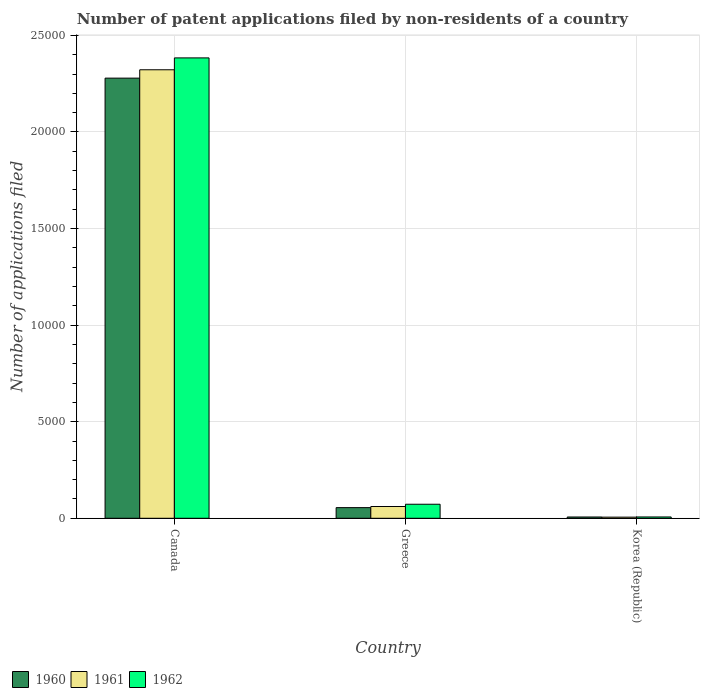How many different coloured bars are there?
Provide a short and direct response. 3. What is the label of the 2nd group of bars from the left?
Your response must be concise. Greece. In how many cases, is the number of bars for a given country not equal to the number of legend labels?
Provide a succinct answer. 0. Across all countries, what is the maximum number of applications filed in 1960?
Offer a very short reply. 2.28e+04. Across all countries, what is the minimum number of applications filed in 1960?
Give a very brief answer. 66. What is the total number of applications filed in 1960 in the graph?
Your response must be concise. 2.34e+04. What is the difference between the number of applications filed in 1960 in Canada and that in Greece?
Provide a succinct answer. 2.22e+04. What is the difference between the number of applications filed in 1961 in Greece and the number of applications filed in 1960 in Canada?
Your answer should be compact. -2.22e+04. What is the average number of applications filed in 1962 per country?
Provide a succinct answer. 8209.33. What is the difference between the number of applications filed of/in 1960 and number of applications filed of/in 1962 in Canada?
Provide a succinct answer. -1048. What is the ratio of the number of applications filed in 1961 in Canada to that in Greece?
Your answer should be very brief. 38.13. Is the difference between the number of applications filed in 1960 in Greece and Korea (Republic) greater than the difference between the number of applications filed in 1962 in Greece and Korea (Republic)?
Provide a succinct answer. No. What is the difference between the highest and the second highest number of applications filed in 1962?
Offer a terse response. 2.38e+04. What is the difference between the highest and the lowest number of applications filed in 1962?
Give a very brief answer. 2.38e+04. Are all the bars in the graph horizontal?
Provide a succinct answer. No. What is the difference between two consecutive major ticks on the Y-axis?
Keep it short and to the point. 5000. Does the graph contain any zero values?
Make the answer very short. No. Where does the legend appear in the graph?
Your answer should be very brief. Bottom left. How many legend labels are there?
Make the answer very short. 3. What is the title of the graph?
Provide a short and direct response. Number of patent applications filed by non-residents of a country. What is the label or title of the Y-axis?
Provide a succinct answer. Number of applications filed. What is the Number of applications filed in 1960 in Canada?
Your answer should be very brief. 2.28e+04. What is the Number of applications filed of 1961 in Canada?
Your answer should be very brief. 2.32e+04. What is the Number of applications filed of 1962 in Canada?
Offer a terse response. 2.38e+04. What is the Number of applications filed in 1960 in Greece?
Provide a succinct answer. 551. What is the Number of applications filed of 1961 in Greece?
Ensure brevity in your answer.  609. What is the Number of applications filed in 1962 in Greece?
Provide a succinct answer. 726. What is the Number of applications filed in 1961 in Korea (Republic)?
Give a very brief answer. 58. What is the Number of applications filed in 1962 in Korea (Republic)?
Keep it short and to the point. 68. Across all countries, what is the maximum Number of applications filed in 1960?
Provide a short and direct response. 2.28e+04. Across all countries, what is the maximum Number of applications filed in 1961?
Your answer should be very brief. 2.32e+04. Across all countries, what is the maximum Number of applications filed of 1962?
Provide a short and direct response. 2.38e+04. Across all countries, what is the minimum Number of applications filed in 1960?
Ensure brevity in your answer.  66. Across all countries, what is the minimum Number of applications filed of 1962?
Keep it short and to the point. 68. What is the total Number of applications filed of 1960 in the graph?
Your answer should be compact. 2.34e+04. What is the total Number of applications filed in 1961 in the graph?
Your answer should be compact. 2.39e+04. What is the total Number of applications filed in 1962 in the graph?
Your answer should be compact. 2.46e+04. What is the difference between the Number of applications filed in 1960 in Canada and that in Greece?
Provide a succinct answer. 2.22e+04. What is the difference between the Number of applications filed in 1961 in Canada and that in Greece?
Your response must be concise. 2.26e+04. What is the difference between the Number of applications filed in 1962 in Canada and that in Greece?
Provide a succinct answer. 2.31e+04. What is the difference between the Number of applications filed in 1960 in Canada and that in Korea (Republic)?
Offer a very short reply. 2.27e+04. What is the difference between the Number of applications filed of 1961 in Canada and that in Korea (Republic)?
Provide a short and direct response. 2.32e+04. What is the difference between the Number of applications filed in 1962 in Canada and that in Korea (Republic)?
Ensure brevity in your answer.  2.38e+04. What is the difference between the Number of applications filed of 1960 in Greece and that in Korea (Republic)?
Provide a succinct answer. 485. What is the difference between the Number of applications filed of 1961 in Greece and that in Korea (Republic)?
Ensure brevity in your answer.  551. What is the difference between the Number of applications filed of 1962 in Greece and that in Korea (Republic)?
Provide a short and direct response. 658. What is the difference between the Number of applications filed in 1960 in Canada and the Number of applications filed in 1961 in Greece?
Provide a short and direct response. 2.22e+04. What is the difference between the Number of applications filed in 1960 in Canada and the Number of applications filed in 1962 in Greece?
Provide a succinct answer. 2.21e+04. What is the difference between the Number of applications filed in 1961 in Canada and the Number of applications filed in 1962 in Greece?
Make the answer very short. 2.25e+04. What is the difference between the Number of applications filed in 1960 in Canada and the Number of applications filed in 1961 in Korea (Republic)?
Offer a terse response. 2.27e+04. What is the difference between the Number of applications filed in 1960 in Canada and the Number of applications filed in 1962 in Korea (Republic)?
Make the answer very short. 2.27e+04. What is the difference between the Number of applications filed in 1961 in Canada and the Number of applications filed in 1962 in Korea (Republic)?
Provide a short and direct response. 2.32e+04. What is the difference between the Number of applications filed of 1960 in Greece and the Number of applications filed of 1961 in Korea (Republic)?
Your answer should be compact. 493. What is the difference between the Number of applications filed of 1960 in Greece and the Number of applications filed of 1962 in Korea (Republic)?
Offer a very short reply. 483. What is the difference between the Number of applications filed in 1961 in Greece and the Number of applications filed in 1962 in Korea (Republic)?
Keep it short and to the point. 541. What is the average Number of applications filed in 1960 per country?
Offer a very short reply. 7801. What is the average Number of applications filed of 1961 per country?
Give a very brief answer. 7962. What is the average Number of applications filed in 1962 per country?
Your response must be concise. 8209.33. What is the difference between the Number of applications filed of 1960 and Number of applications filed of 1961 in Canada?
Your answer should be compact. -433. What is the difference between the Number of applications filed of 1960 and Number of applications filed of 1962 in Canada?
Offer a terse response. -1048. What is the difference between the Number of applications filed of 1961 and Number of applications filed of 1962 in Canada?
Keep it short and to the point. -615. What is the difference between the Number of applications filed of 1960 and Number of applications filed of 1961 in Greece?
Your answer should be very brief. -58. What is the difference between the Number of applications filed of 1960 and Number of applications filed of 1962 in Greece?
Ensure brevity in your answer.  -175. What is the difference between the Number of applications filed of 1961 and Number of applications filed of 1962 in Greece?
Your response must be concise. -117. What is the difference between the Number of applications filed in 1960 and Number of applications filed in 1962 in Korea (Republic)?
Give a very brief answer. -2. What is the difference between the Number of applications filed of 1961 and Number of applications filed of 1962 in Korea (Republic)?
Provide a short and direct response. -10. What is the ratio of the Number of applications filed of 1960 in Canada to that in Greece?
Make the answer very short. 41.35. What is the ratio of the Number of applications filed of 1961 in Canada to that in Greece?
Offer a terse response. 38.13. What is the ratio of the Number of applications filed in 1962 in Canada to that in Greece?
Your answer should be compact. 32.83. What is the ratio of the Number of applications filed in 1960 in Canada to that in Korea (Republic)?
Give a very brief answer. 345.24. What is the ratio of the Number of applications filed of 1961 in Canada to that in Korea (Republic)?
Provide a succinct answer. 400.33. What is the ratio of the Number of applications filed of 1962 in Canada to that in Korea (Republic)?
Your answer should be very brief. 350.5. What is the ratio of the Number of applications filed of 1960 in Greece to that in Korea (Republic)?
Your answer should be compact. 8.35. What is the ratio of the Number of applications filed of 1962 in Greece to that in Korea (Republic)?
Make the answer very short. 10.68. What is the difference between the highest and the second highest Number of applications filed of 1960?
Your answer should be compact. 2.22e+04. What is the difference between the highest and the second highest Number of applications filed of 1961?
Keep it short and to the point. 2.26e+04. What is the difference between the highest and the second highest Number of applications filed of 1962?
Offer a terse response. 2.31e+04. What is the difference between the highest and the lowest Number of applications filed in 1960?
Your answer should be compact. 2.27e+04. What is the difference between the highest and the lowest Number of applications filed of 1961?
Ensure brevity in your answer.  2.32e+04. What is the difference between the highest and the lowest Number of applications filed in 1962?
Ensure brevity in your answer.  2.38e+04. 